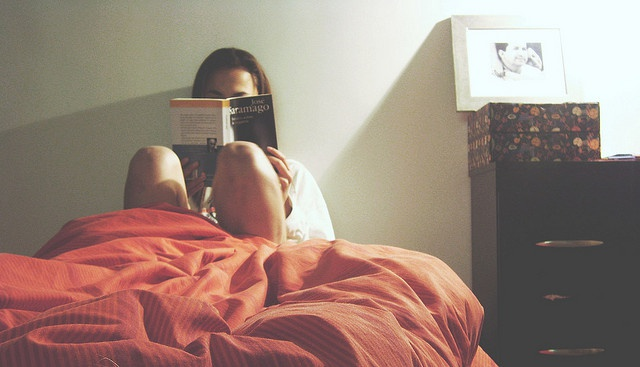Describe the objects in this image and their specific colors. I can see bed in gray, brown, and salmon tones, people in gray, brown, ivory, and tan tones, and book in gray and lightgray tones in this image. 